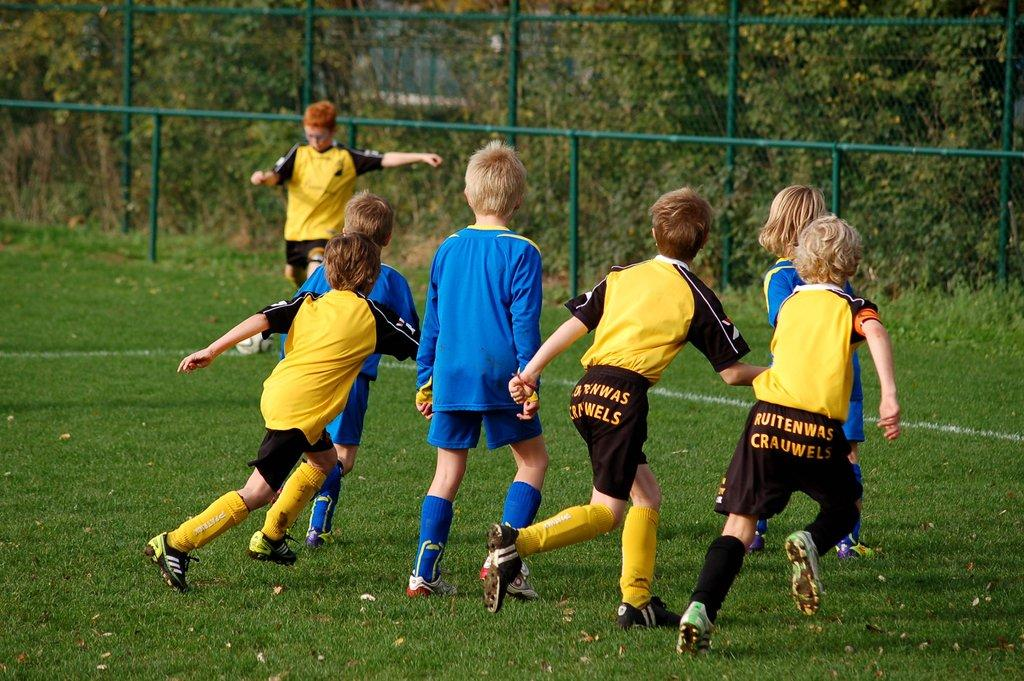Provide a one-sentence caption for the provided image. Childrens soccer team called Ruitenwas Crauwels wearing black and yellow uniforms. 